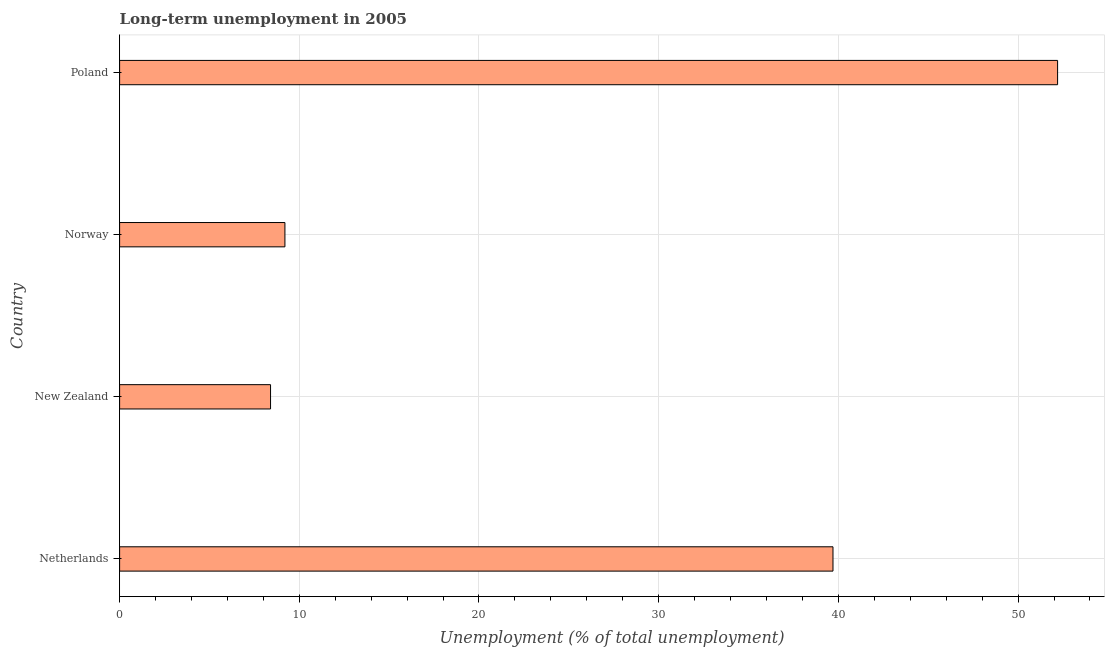Does the graph contain any zero values?
Give a very brief answer. No. Does the graph contain grids?
Make the answer very short. Yes. What is the title of the graph?
Ensure brevity in your answer.  Long-term unemployment in 2005. What is the label or title of the X-axis?
Offer a very short reply. Unemployment (% of total unemployment). What is the long-term unemployment in Norway?
Provide a short and direct response. 9.2. Across all countries, what is the maximum long-term unemployment?
Ensure brevity in your answer.  52.2. Across all countries, what is the minimum long-term unemployment?
Your answer should be compact. 8.4. In which country was the long-term unemployment maximum?
Ensure brevity in your answer.  Poland. In which country was the long-term unemployment minimum?
Provide a short and direct response. New Zealand. What is the sum of the long-term unemployment?
Provide a succinct answer. 109.5. What is the difference between the long-term unemployment in Netherlands and Norway?
Your answer should be very brief. 30.5. What is the average long-term unemployment per country?
Give a very brief answer. 27.38. What is the median long-term unemployment?
Offer a very short reply. 24.45. In how many countries, is the long-term unemployment greater than 48 %?
Your answer should be very brief. 1. What is the ratio of the long-term unemployment in Netherlands to that in Poland?
Provide a short and direct response. 0.76. Is the difference between the long-term unemployment in New Zealand and Poland greater than the difference between any two countries?
Provide a succinct answer. Yes. What is the difference between the highest and the lowest long-term unemployment?
Keep it short and to the point. 43.8. What is the Unemployment (% of total unemployment) in Netherlands?
Make the answer very short. 39.7. What is the Unemployment (% of total unemployment) of New Zealand?
Provide a short and direct response. 8.4. What is the Unemployment (% of total unemployment) in Norway?
Make the answer very short. 9.2. What is the Unemployment (% of total unemployment) of Poland?
Give a very brief answer. 52.2. What is the difference between the Unemployment (% of total unemployment) in Netherlands and New Zealand?
Provide a short and direct response. 31.3. What is the difference between the Unemployment (% of total unemployment) in Netherlands and Norway?
Offer a terse response. 30.5. What is the difference between the Unemployment (% of total unemployment) in New Zealand and Poland?
Your answer should be very brief. -43.8. What is the difference between the Unemployment (% of total unemployment) in Norway and Poland?
Provide a short and direct response. -43. What is the ratio of the Unemployment (% of total unemployment) in Netherlands to that in New Zealand?
Your response must be concise. 4.73. What is the ratio of the Unemployment (% of total unemployment) in Netherlands to that in Norway?
Give a very brief answer. 4.32. What is the ratio of the Unemployment (% of total unemployment) in Netherlands to that in Poland?
Offer a very short reply. 0.76. What is the ratio of the Unemployment (% of total unemployment) in New Zealand to that in Norway?
Keep it short and to the point. 0.91. What is the ratio of the Unemployment (% of total unemployment) in New Zealand to that in Poland?
Your answer should be very brief. 0.16. What is the ratio of the Unemployment (% of total unemployment) in Norway to that in Poland?
Give a very brief answer. 0.18. 